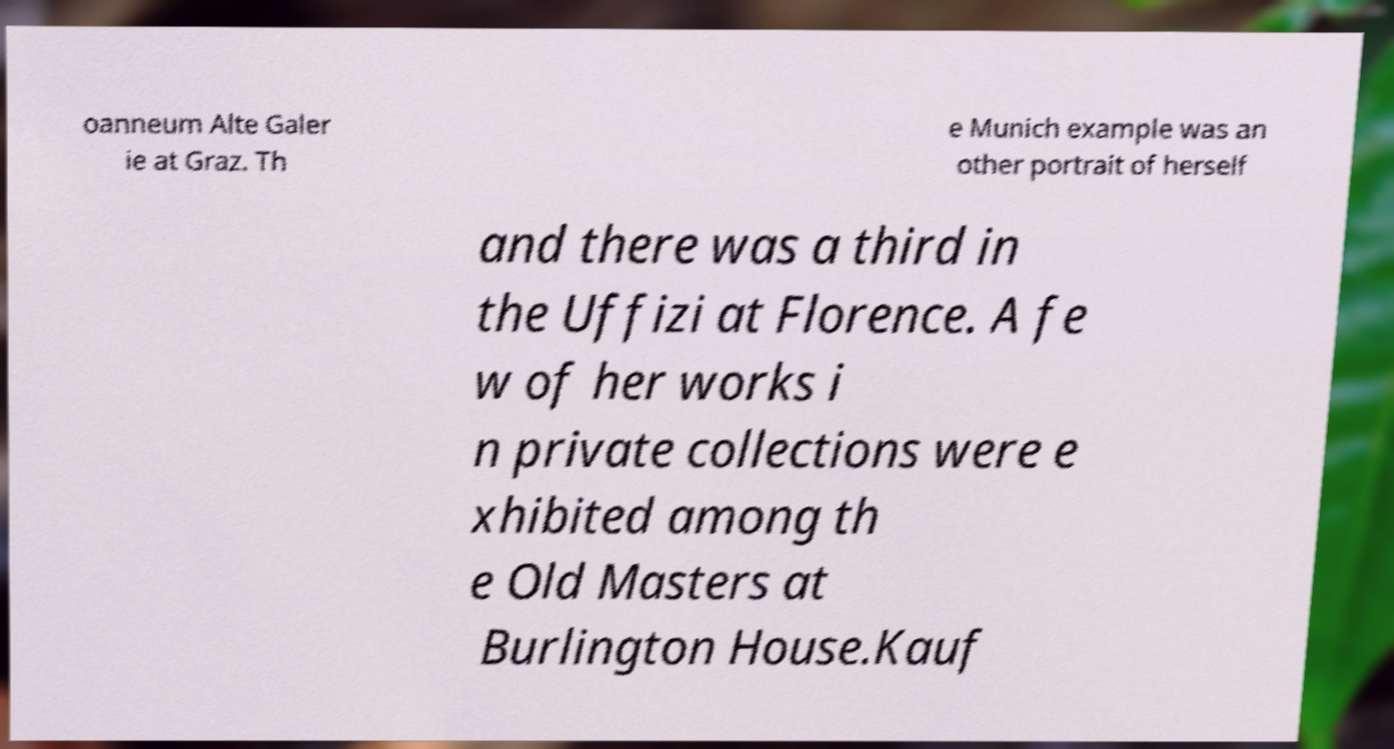Could you assist in decoding the text presented in this image and type it out clearly? oanneum Alte Galer ie at Graz. Th e Munich example was an other portrait of herself and there was a third in the Uffizi at Florence. A fe w of her works i n private collections were e xhibited among th e Old Masters at Burlington House.Kauf 